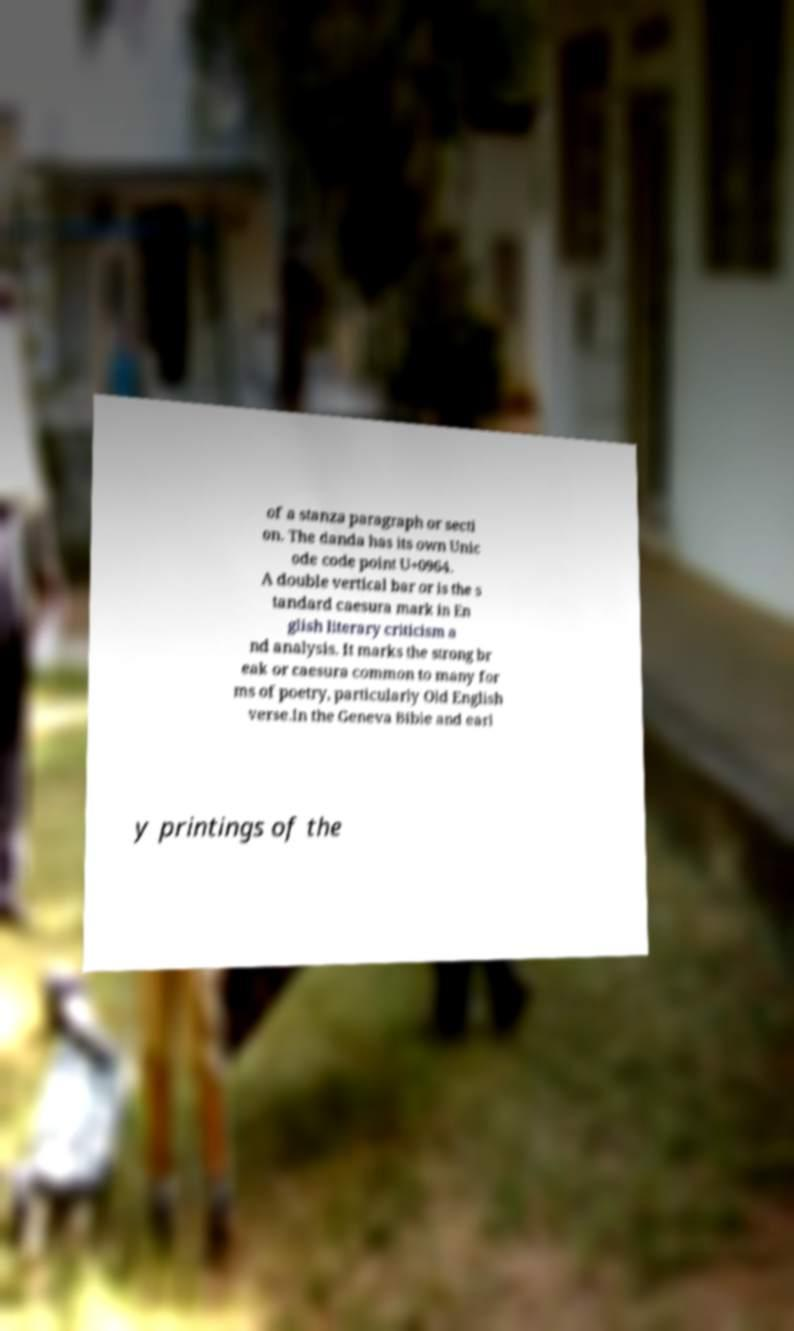For documentation purposes, I need the text within this image transcribed. Could you provide that? of a stanza paragraph or secti on. The danda has its own Unic ode code point U+0964. A double vertical bar or is the s tandard caesura mark in En glish literary criticism a nd analysis. It marks the strong br eak or caesura common to many for ms of poetry, particularly Old English verse.In the Geneva Bible and earl y printings of the 